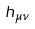<formula> <loc_0><loc_0><loc_500><loc_500>h _ { \mu \nu }</formula> 